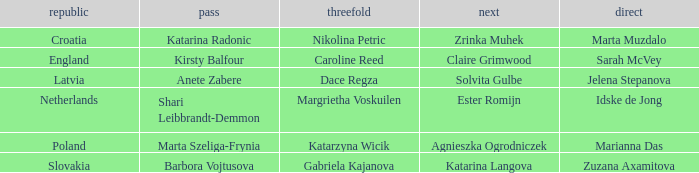What is the name of the second who has Caroline Reed as third? Claire Grimwood. 